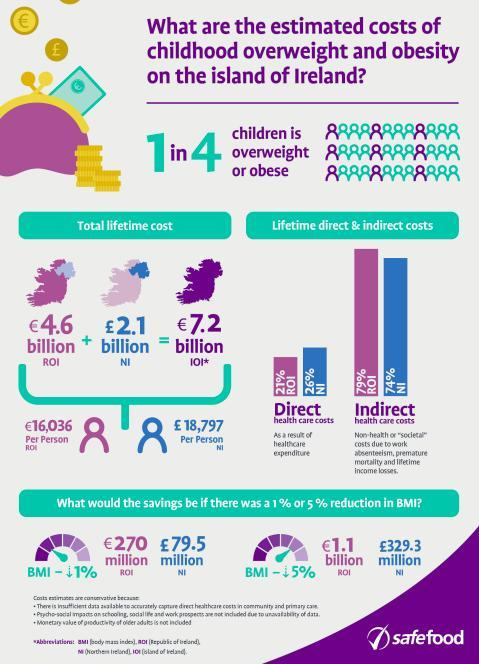What is the total average percentage of direct health care costs in Republic of Ireland and Northern Ireland?
Answer the question with a short phrase. 25% What is the difference in savings of Republic of Ireland and Northern Ireland in million pounds if the BMI is reduced 5%? 328.2 What is the difference in savings of Republic of Ireland and Northern Ireland in million pounds if the BMI is reduced 1%? 190.5 What is the total average percentage of indirect health care costs in Republic of Ireland and Northern Ireland? 76.5% 